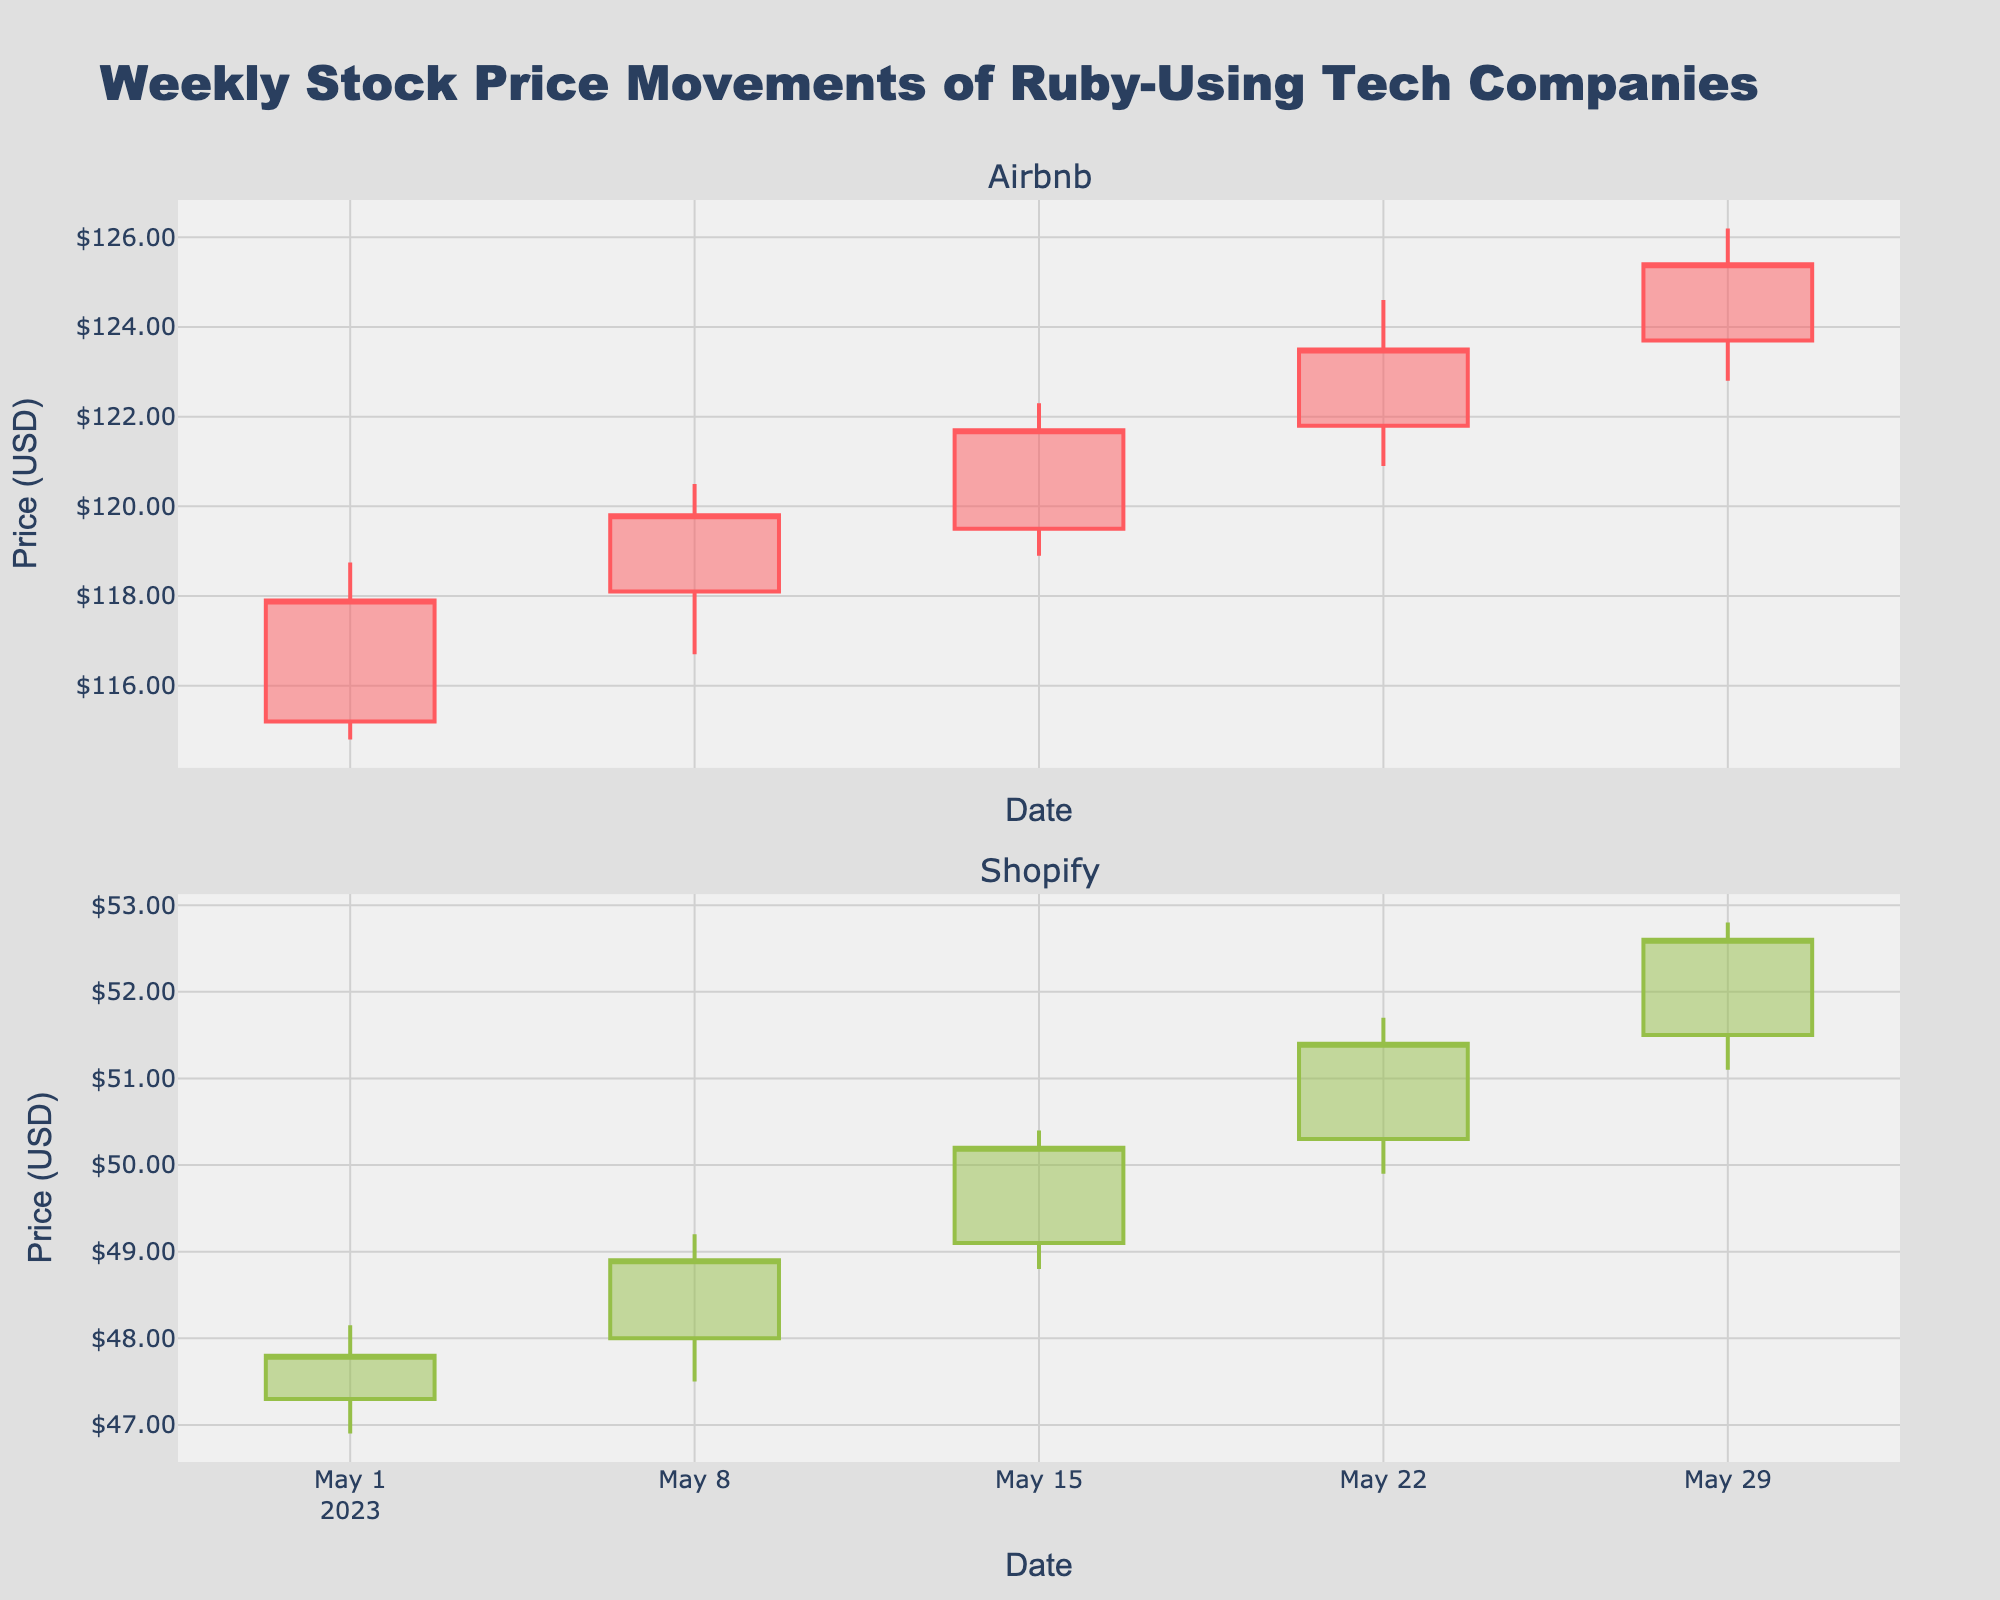How many companies are shown in the figure? The figure has two subplots, each representing a different company.
Answer: 2 Which company had the highest closing price on May 29, 2023? By looking at the closing prices for May 29, Airbnb had a closing price of $125.40, whereas Shopify had a closing price of $52.60. Therefore, Airbnb had the highest closing price on that date.
Answer: Airbnb Across the given weeks, did Airbnb's stock price show a general upward or downward trend? Observing the closing prices of Airbnb from May 1 to May 29, the prices are: $117.90, $119.80, $121.70, $123.50, $125.40. Since the closing prices are increasing each week, Airbnb's stock price showed an upward trend.
Answer: Upward What was Shopify's highest high price recorded during the given period? Shopify's high prices across the weeks are: $48.15, $49.20, $50.40, $51.70, $52.80. The highest among these is $52.80.
Answer: $52.80 Comparing both companies, which one had a greater increase in closing price from May 1 to May 29? Airbnb's closing price increased from $117.90 to $125.40, an increase of $7.50. Shopify's closing price increased from $47.80 to $52.60, an increase of $4.80. Therefore, Airbnb had a greater increase in closing price.
Answer: Airbnb What was the lowest low price for Airbnb during the period? Airbnb's low prices across the weeks are: $114.80, $116.70, $118.90, $120.90, $122.80. The lowest among these is $114.80.
Answer: $114.80 Between the weeks of May 8 and May 15, which company showed a higher percentage increase in closing price? Airbnb's closing price increased from $119.80 to $121.70, an increase of $1.90. The percentage increase is ($1.90 / $119.80) * 100 ≈ 1.59%. Shopify's closing price increased from $48.90 to $50.20, an increase of $1.30. The percentage increase is ($1.30 / $48.90) * 100 ≈ 2.66%. Therefore, Shopify showed a higher percentage increase.
Answer: Shopify What was the total range of Airbnb's stock prices (difference between the highest high and lowest low) within the given weeks? Airbnb's highest high was $126.20, and its lowest low was $114.80. The range is $126.20 - $114.80 = $11.40.
Answer: $11.40 